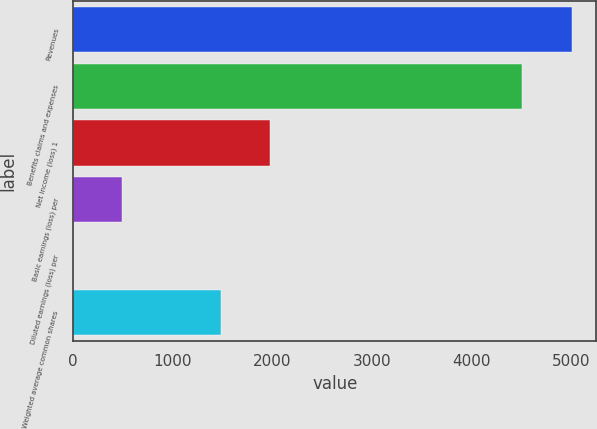Convert chart. <chart><loc_0><loc_0><loc_500><loc_500><bar_chart><fcel>Revenues<fcel>Benefits claims and expenses<fcel>Net income (loss) 1<fcel>Basic earnings (loss) per<fcel>Diluted earnings (loss) per<fcel>Weighted average common shares<nl><fcel>5005.58<fcel>4511<fcel>1979.52<fcel>495.78<fcel>1.2<fcel>1484.94<nl></chart> 